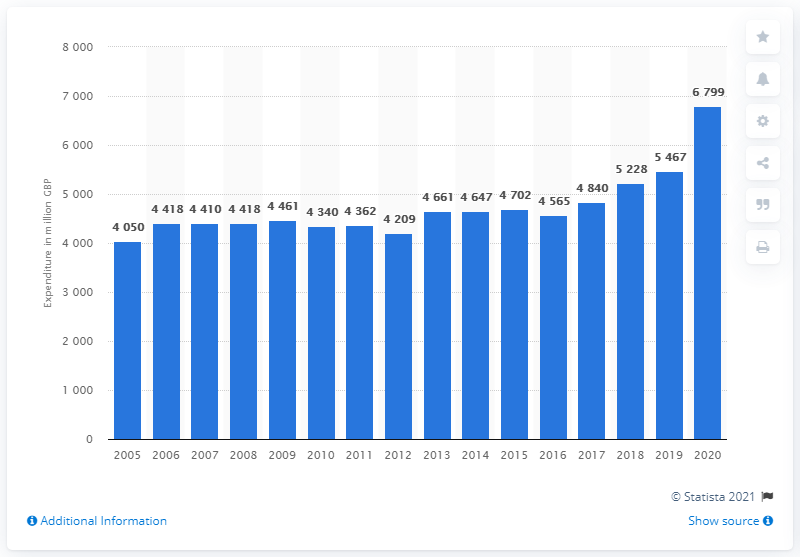Mention a couple of crucial points in this snapshot. In 2020, the United Kingdom spent approximately 6,799 British pounds on beer. The amount spent on beer in the UK has increased significantly since 2005. 